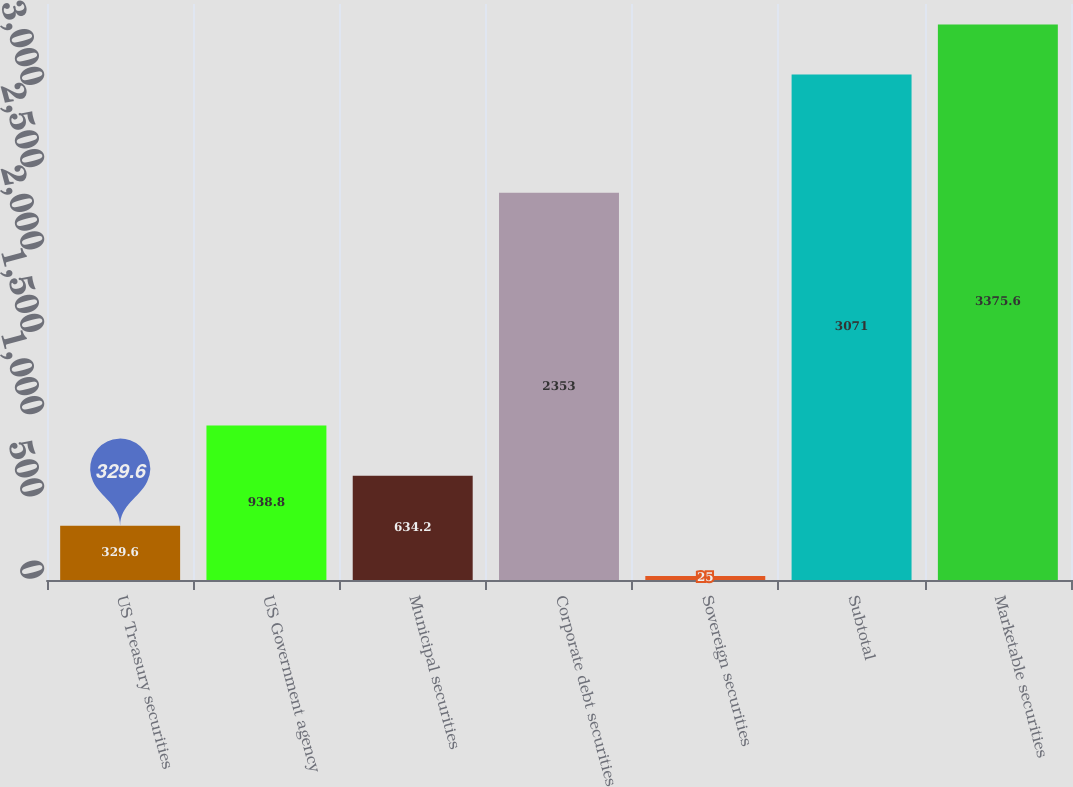Convert chart. <chart><loc_0><loc_0><loc_500><loc_500><bar_chart><fcel>US Treasury securities<fcel>US Government agency<fcel>Municipal securities<fcel>Corporate debt securities<fcel>Sovereign securities<fcel>Subtotal<fcel>Marketable securities<nl><fcel>329.6<fcel>938.8<fcel>634.2<fcel>2353<fcel>25<fcel>3071<fcel>3375.6<nl></chart> 